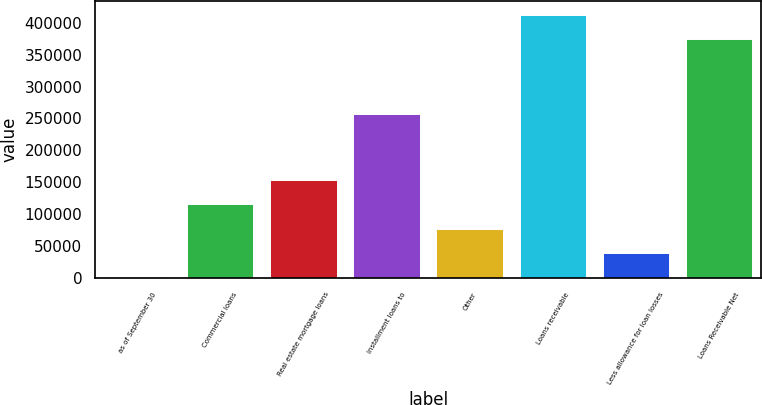Convert chart to OTSL. <chart><loc_0><loc_0><loc_500><loc_500><bar_chart><fcel>as of September 30<fcel>Commercial loans<fcel>Real estate mortgage loans<fcel>Installment loans to<fcel>Other<fcel>Loans receivable<fcel>Less allowance for loan losses<fcel>Loans Receivable Net<nl><fcel>2010<fcel>115508<fcel>153340<fcel>257460<fcel>77675<fcel>412718<fcel>39842.5<fcel>374886<nl></chart> 